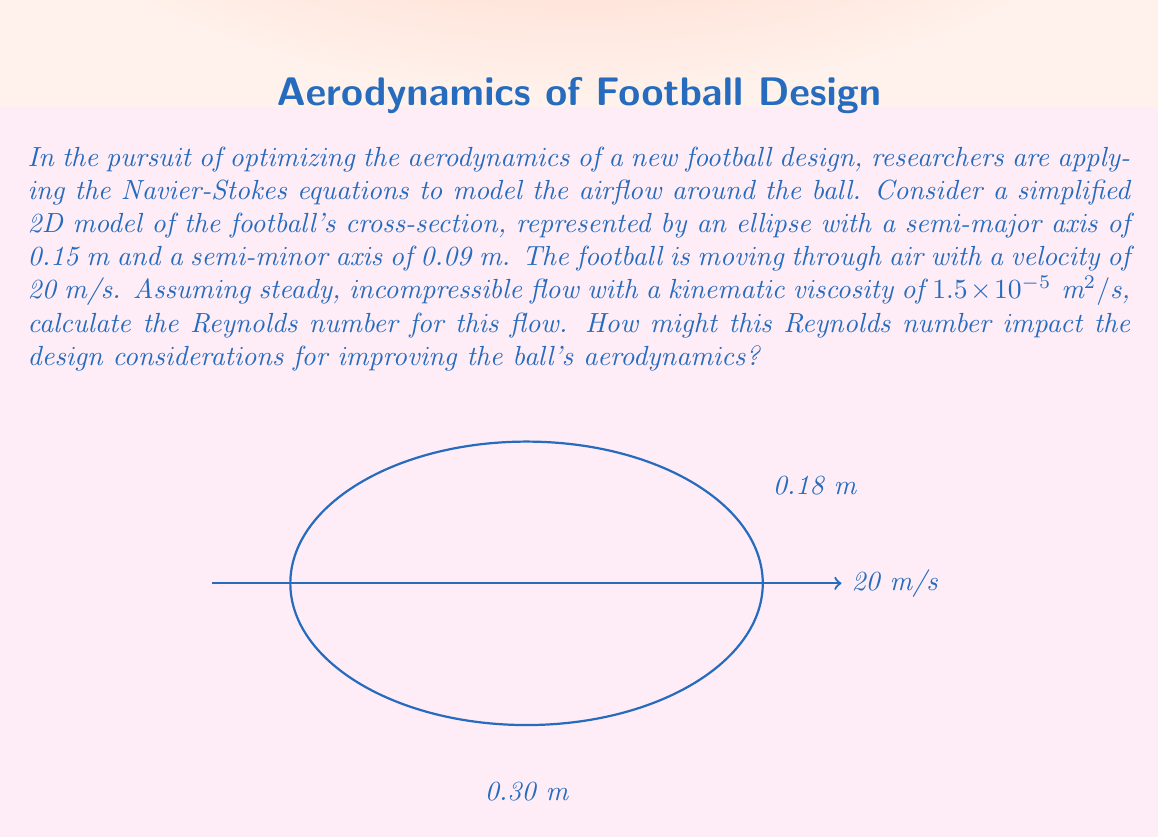Show me your answer to this math problem. To solve this problem, we need to follow these steps:

1) The Reynolds number (Re) is given by the formula:

   $$ Re = \frac{UL}{\nu} $$

   Where:
   - $U$ is the flow velocity
   - $L$ is the characteristic length
   - $\nu$ is the kinematic viscosity

2) We're given:
   - $U = 20 \text{ m/s}$
   - $\nu = 1.5 \times 10^{-5} \text{ m}^2/\text{s}$

3) For the characteristic length $L$, we'll use the diameter along the direction of flow, which is the major axis of the ellipse:

   $L = 2 \times 0.15 \text{ m} = 0.30 \text{ m}$

4) Now we can substitute these values into the Reynolds number formula:

   $$ Re = \frac{(20 \text{ m/s})(0.30 \text{ m})}{1.5 \times 10^{-5} \text{ m}^2/\text{s}} $$

5) Calculating:

   $$ Re = \frac{6}{1.5 \times 10^{-5}} = 4 \times 10^5 $$

6) This Reynolds number (400,000) indicates turbulent flow, which has significant implications for the ball's aerodynamics:

   a) Turbulent flow increases drag, which could affect the ball's trajectory and distance.
   b) The separation point of the boundary layer will be delayed compared to laminar flow, potentially reducing the wake and overall drag.
   c) The surface roughness of the ball becomes crucial, as it can trigger the transition to turbulent flow earlier, potentially reducing drag at certain speeds (this is why golf balls have dimples).

7) Design considerations based on this Reynolds number:
   - Optimize surface texture (like the seams on a football) to control boundary layer transition.
   - Consider slight modifications to the ball's shape to manage the separation point and reduce wake.
   - Explore materials that can maintain consistent surface characteristics under various weather conditions.
Answer: $Re = 4 \times 10^5$; Turbulent flow regime requires focus on surface texture and shape optimization to manage drag and boundary layer separation. 